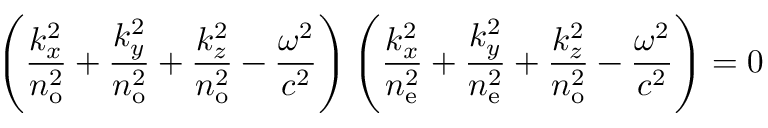<formula> <loc_0><loc_0><loc_500><loc_500>\left ( { \frac { k _ { x } ^ { 2 } } { n _ { o } ^ { 2 } } } + { \frac { k _ { y } ^ { 2 } } { n _ { o } ^ { 2 } } } + { \frac { k _ { z } ^ { 2 } } { n _ { o } ^ { 2 } } } - { \frac { \omega ^ { 2 } } { c ^ { 2 } } } \right ) \left ( { \frac { k _ { x } ^ { 2 } } { n _ { e } ^ { 2 } } } + { \frac { k _ { y } ^ { 2 } } { n _ { e } ^ { 2 } } } + { \frac { k _ { z } ^ { 2 } } { n _ { o } ^ { 2 } } } - { \frac { \omega ^ { 2 } } { c ^ { 2 } } } \right ) = 0</formula> 